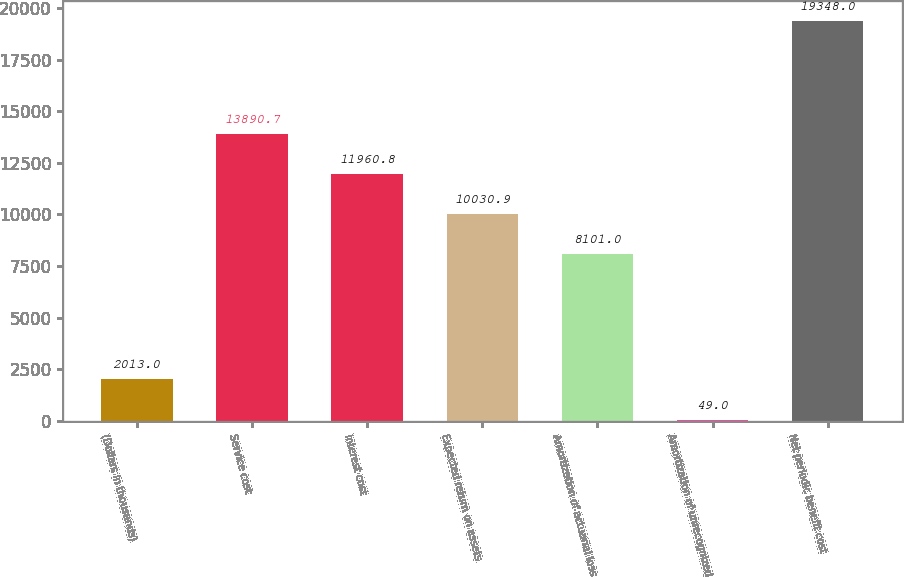<chart> <loc_0><loc_0><loc_500><loc_500><bar_chart><fcel>(Dollars in thousands)<fcel>Service cost<fcel>Interest cost<fcel>Expected return on assets<fcel>Amortization of actuarial loss<fcel>Amortization of unrecognized<fcel>Net periodic benefit cost<nl><fcel>2013<fcel>13890.7<fcel>11960.8<fcel>10030.9<fcel>8101<fcel>49<fcel>19348<nl></chart> 